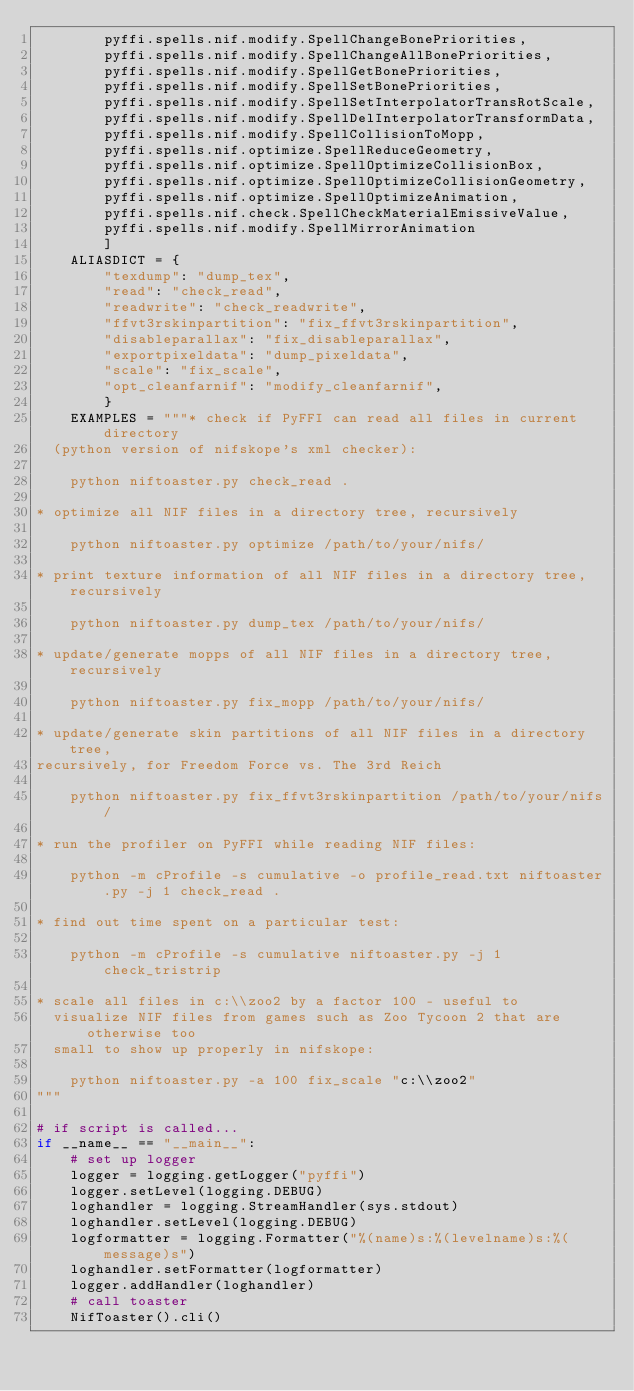<code> <loc_0><loc_0><loc_500><loc_500><_Python_>        pyffi.spells.nif.modify.SpellChangeBonePriorities,
        pyffi.spells.nif.modify.SpellChangeAllBonePriorities,
        pyffi.spells.nif.modify.SpellGetBonePriorities,
        pyffi.spells.nif.modify.SpellSetBonePriorities,
        pyffi.spells.nif.modify.SpellSetInterpolatorTransRotScale,
        pyffi.spells.nif.modify.SpellDelInterpolatorTransformData,
        pyffi.spells.nif.modify.SpellCollisionToMopp,
        pyffi.spells.nif.optimize.SpellReduceGeometry,
        pyffi.spells.nif.optimize.SpellOptimizeCollisionBox,
        pyffi.spells.nif.optimize.SpellOptimizeCollisionGeometry,
        pyffi.spells.nif.optimize.SpellOptimizeAnimation,
        pyffi.spells.nif.check.SpellCheckMaterialEmissiveValue,
        pyffi.spells.nif.modify.SpellMirrorAnimation
        ]
    ALIASDICT = {
        "texdump": "dump_tex",
        "read": "check_read",
        "readwrite": "check_readwrite",
        "ffvt3rskinpartition": "fix_ffvt3rskinpartition",
        "disableparallax": "fix_disableparallax",
        "exportpixeldata": "dump_pixeldata",
        "scale": "fix_scale",
        "opt_cleanfarnif": "modify_cleanfarnif",
        }
    EXAMPLES = """* check if PyFFI can read all files in current directory
  (python version of nifskope's xml checker):

    python niftoaster.py check_read .

* optimize all NIF files in a directory tree, recursively

    python niftoaster.py optimize /path/to/your/nifs/

* print texture information of all NIF files in a directory tree, recursively

    python niftoaster.py dump_tex /path/to/your/nifs/

* update/generate mopps of all NIF files in a directory tree, recursively

    python niftoaster.py fix_mopp /path/to/your/nifs/

* update/generate skin partitions of all NIF files in a directory tree,
recursively, for Freedom Force vs. The 3rd Reich

    python niftoaster.py fix_ffvt3rskinpartition /path/to/your/nifs/

* run the profiler on PyFFI while reading NIF files:

    python -m cProfile -s cumulative -o profile_read.txt niftoaster.py -j 1 check_read .

* find out time spent on a particular test:

    python -m cProfile -s cumulative niftoaster.py -j 1 check_tristrip

* scale all files in c:\\zoo2 by a factor 100 - useful to
  visualize NIF files from games such as Zoo Tycoon 2 that are otherwise too
  small to show up properly in nifskope:

    python niftoaster.py -a 100 fix_scale "c:\\zoo2"
"""

# if script is called...
if __name__ == "__main__":
    # set up logger
    logger = logging.getLogger("pyffi")
    logger.setLevel(logging.DEBUG)
    loghandler = logging.StreamHandler(sys.stdout)
    loghandler.setLevel(logging.DEBUG)
    logformatter = logging.Formatter("%(name)s:%(levelname)s:%(message)s")
    loghandler.setFormatter(logformatter)
    logger.addHandler(loghandler)
    # call toaster
    NifToaster().cli()

</code> 